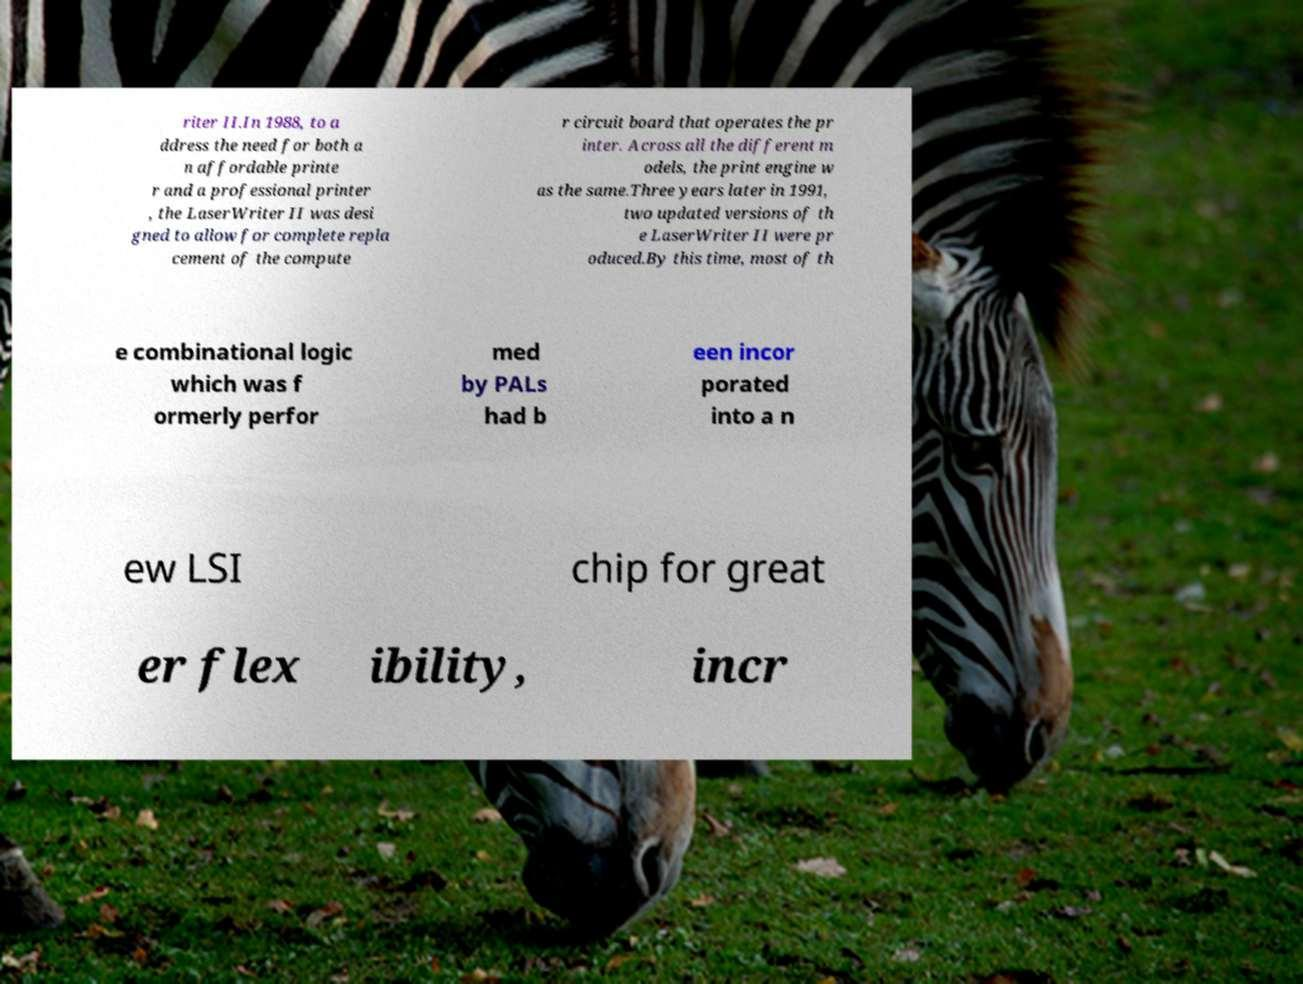Can you read and provide the text displayed in the image?This photo seems to have some interesting text. Can you extract and type it out for me? riter II.In 1988, to a ddress the need for both a n affordable printe r and a professional printer , the LaserWriter II was desi gned to allow for complete repla cement of the compute r circuit board that operates the pr inter. Across all the different m odels, the print engine w as the same.Three years later in 1991, two updated versions of th e LaserWriter II were pr oduced.By this time, most of th e combinational logic which was f ormerly perfor med by PALs had b een incor porated into a n ew LSI chip for great er flex ibility, incr 